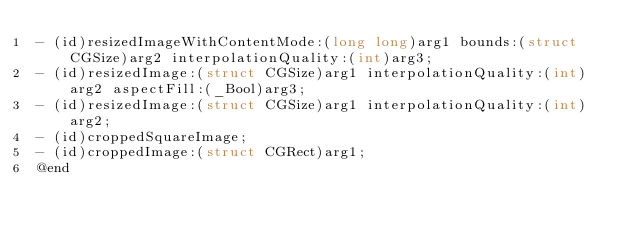Convert code to text. <code><loc_0><loc_0><loc_500><loc_500><_C_>- (id)resizedImageWithContentMode:(long long)arg1 bounds:(struct CGSize)arg2 interpolationQuality:(int)arg3;
- (id)resizedImage:(struct CGSize)arg1 interpolationQuality:(int)arg2 aspectFill:(_Bool)arg3;
- (id)resizedImage:(struct CGSize)arg1 interpolationQuality:(int)arg2;
- (id)croppedSquareImage;
- (id)croppedImage:(struct CGRect)arg1;
@end

</code> 